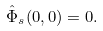<formula> <loc_0><loc_0><loc_500><loc_500>\hat { \Phi } _ { s } ( 0 , 0 ) = 0 .</formula> 